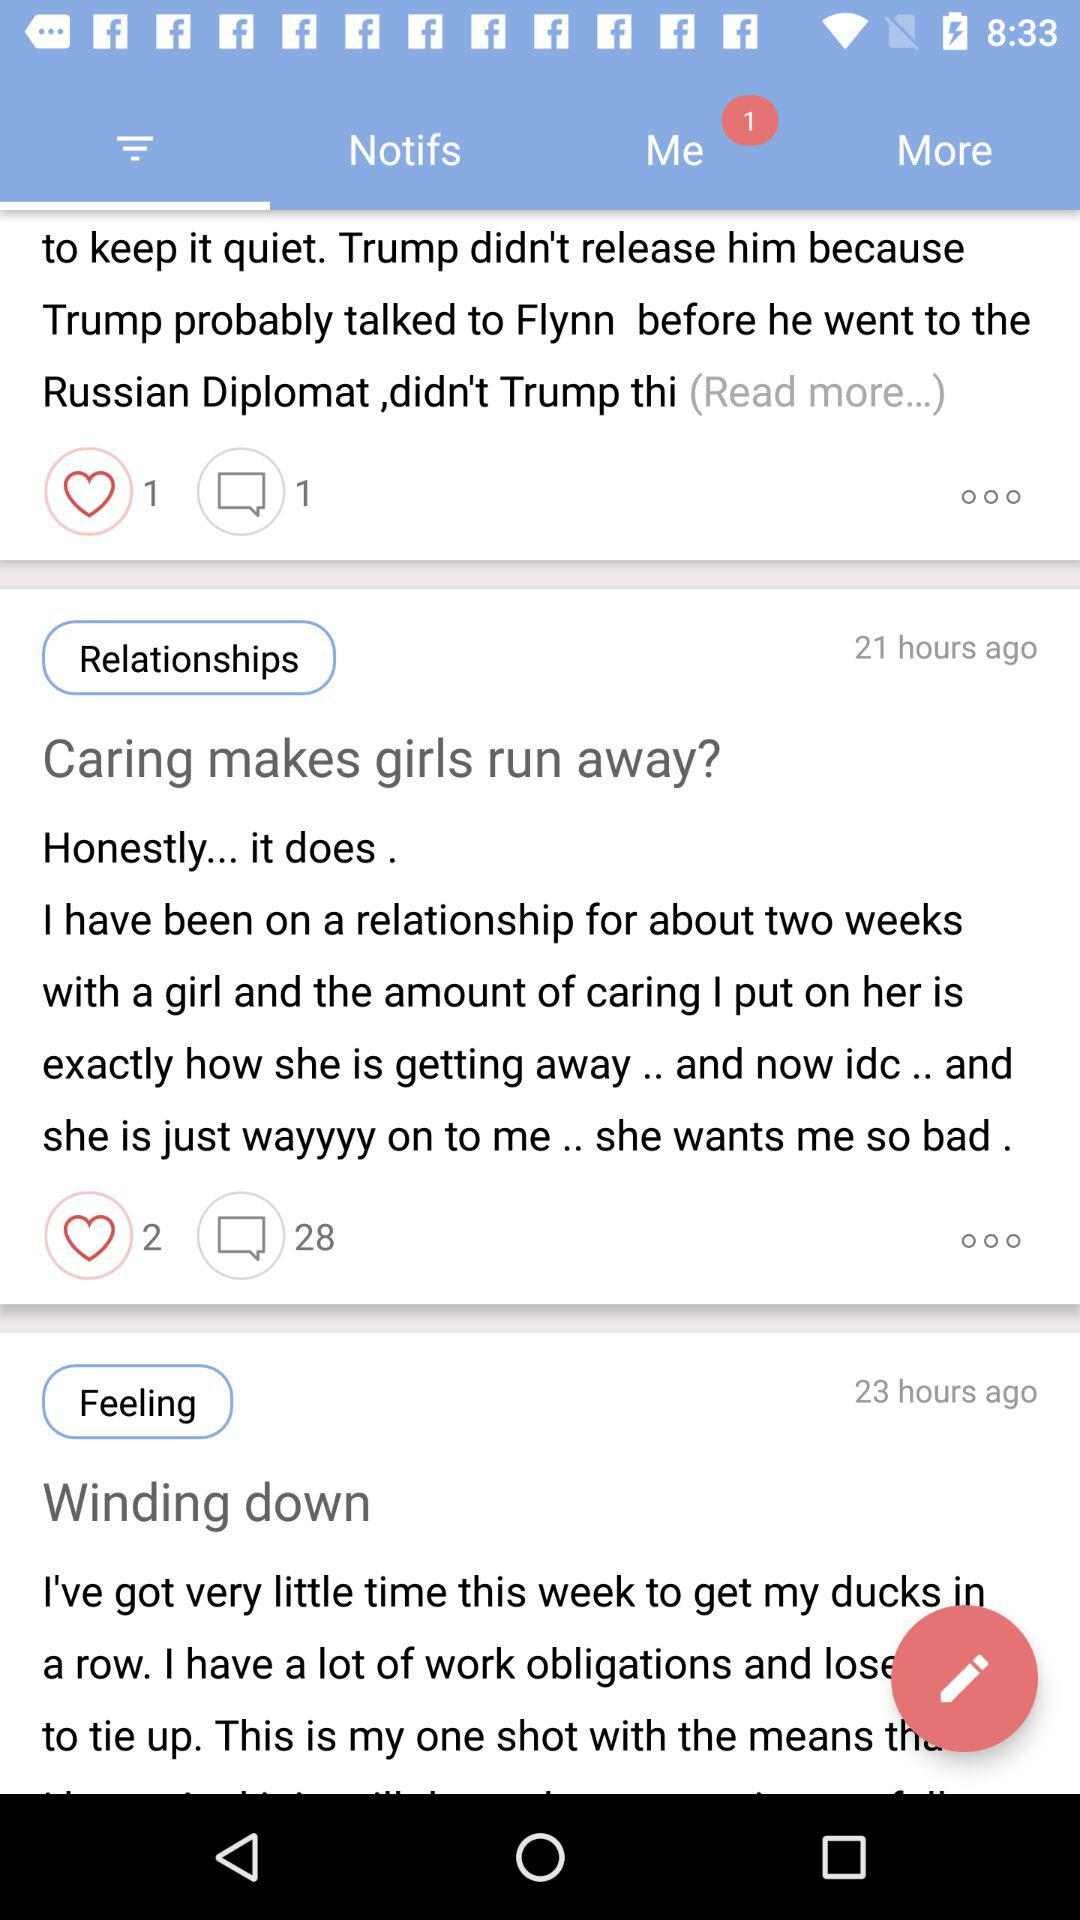How many notifications are there? There is 1 notification. 